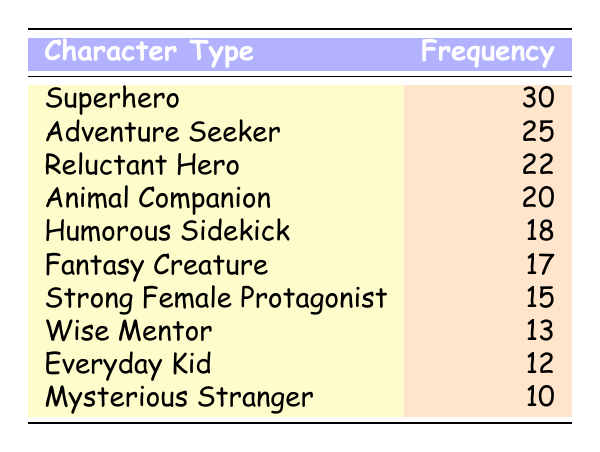What is the character type with the highest frequency? The character type with the highest frequency is listed as "Superhero," which has a frequency of 30 in the table.
Answer: Superhero How many more "Adventure Seekers" are there than "Mysterious Strangers"? There are 25 "Adventure Seekers" and 10 "Mysterious Strangers." The difference is calculated as 25 - 10 = 15.
Answer: 15 Is the frequency of "Everyday Kid" higher than that of "Strong Female Protagonist"? "Everyday Kid" has a frequency of 12 while "Strong Female Protagonist" has a frequency of 15. Since 12 is less than 15, the statement is false.
Answer: No What is the total frequency for "Animal Companion," "Fantasy Creature," and "Humorous Sidekick"? The frequencies for these character types are as follows: "Animal Companion" has 20, "Fantasy Creature" has 17, and "Humorous Sidekick" has 18. Adding these gives 20 + 17 + 18 = 55.
Answer: 55 Which character type has the lowest frequency? The character type with the lowest frequency is "Mysterious Stranger," which has a frequency of 10.
Answer: Mysterious Stranger What is the average frequency of all the character types listed? The sum of all frequencies is 30 + 25 + 22 + 20 + 18 + 17 + 15 + 13 + 12 + 10 =  252. There are 10 character types, so the average is 252 / 10 = 25.2.
Answer: 25.2 Are there more characters in the "Reluctant Hero" category than in the "Wise Mentor" category? "Reluctant Hero" has a frequency of 22 while "Wise Mentor" has a frequency of 13. Since 22 is greater than 13, the statement is true.
Answer: Yes What percentage of the total character types does the "Superhero" category represent? The frequency of "Superhero" is 30. The total frequency is 252. The percentage is calculated as (30 / 252) * 100, which equals approximately 11.9%.
Answer: 11.9% 